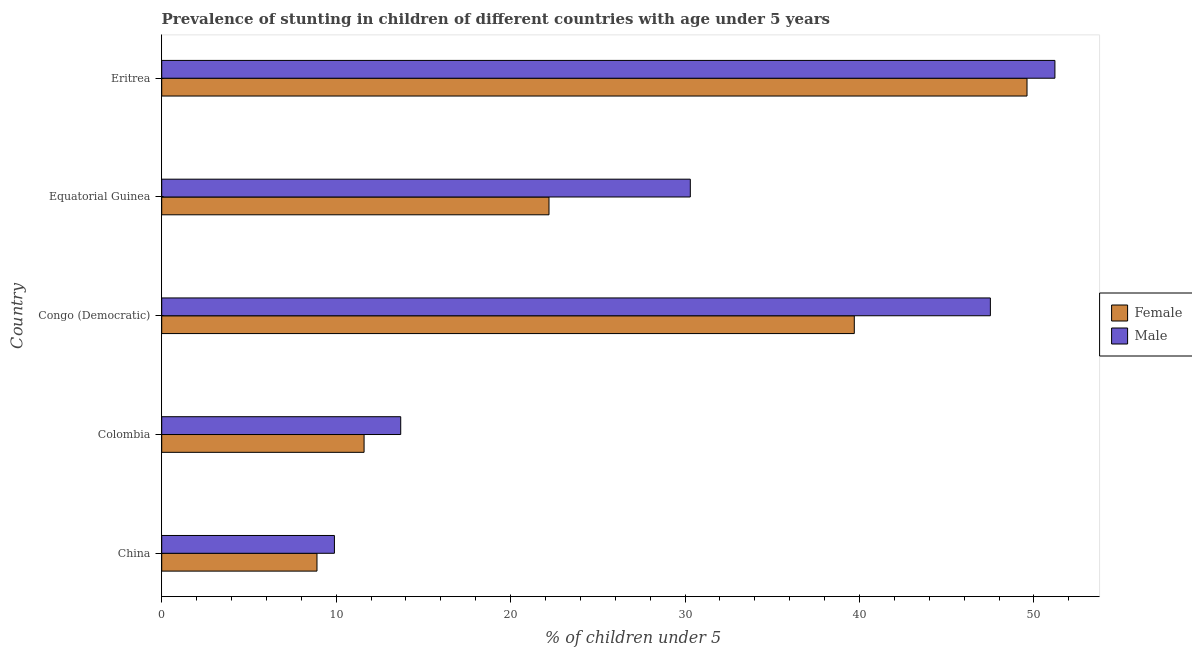How many different coloured bars are there?
Your answer should be very brief. 2. Are the number of bars on each tick of the Y-axis equal?
Your answer should be compact. Yes. How many bars are there on the 5th tick from the top?
Make the answer very short. 2. What is the label of the 1st group of bars from the top?
Keep it short and to the point. Eritrea. What is the percentage of stunted male children in Eritrea?
Provide a succinct answer. 51.2. Across all countries, what is the maximum percentage of stunted female children?
Offer a terse response. 49.6. Across all countries, what is the minimum percentage of stunted male children?
Give a very brief answer. 9.9. In which country was the percentage of stunted male children maximum?
Your response must be concise. Eritrea. What is the total percentage of stunted male children in the graph?
Give a very brief answer. 152.6. What is the difference between the percentage of stunted male children in Colombia and that in Equatorial Guinea?
Provide a succinct answer. -16.6. What is the difference between the percentage of stunted male children in Colombia and the percentage of stunted female children in Congo (Democratic)?
Your answer should be very brief. -26. What is the average percentage of stunted male children per country?
Ensure brevity in your answer.  30.52. In how many countries, is the percentage of stunted female children greater than 46 %?
Offer a very short reply. 1. What is the ratio of the percentage of stunted male children in Colombia to that in Equatorial Guinea?
Give a very brief answer. 0.45. What is the difference between the highest and the lowest percentage of stunted male children?
Provide a short and direct response. 41.3. Is the sum of the percentage of stunted female children in Congo (Democratic) and Equatorial Guinea greater than the maximum percentage of stunted male children across all countries?
Your answer should be very brief. Yes. How many bars are there?
Provide a short and direct response. 10. How many countries are there in the graph?
Provide a short and direct response. 5. Are the values on the major ticks of X-axis written in scientific E-notation?
Your answer should be compact. No. Does the graph contain any zero values?
Ensure brevity in your answer.  No. What is the title of the graph?
Keep it short and to the point. Prevalence of stunting in children of different countries with age under 5 years. What is the label or title of the X-axis?
Keep it short and to the point.  % of children under 5. What is the label or title of the Y-axis?
Keep it short and to the point. Country. What is the  % of children under 5 in Female in China?
Keep it short and to the point. 8.9. What is the  % of children under 5 of Male in China?
Provide a succinct answer. 9.9. What is the  % of children under 5 of Female in Colombia?
Offer a very short reply. 11.6. What is the  % of children under 5 in Male in Colombia?
Your response must be concise. 13.7. What is the  % of children under 5 of Female in Congo (Democratic)?
Offer a very short reply. 39.7. What is the  % of children under 5 of Male in Congo (Democratic)?
Make the answer very short. 47.5. What is the  % of children under 5 in Female in Equatorial Guinea?
Your response must be concise. 22.2. What is the  % of children under 5 of Male in Equatorial Guinea?
Your response must be concise. 30.3. What is the  % of children under 5 of Female in Eritrea?
Your answer should be very brief. 49.6. What is the  % of children under 5 in Male in Eritrea?
Ensure brevity in your answer.  51.2. Across all countries, what is the maximum  % of children under 5 of Female?
Provide a short and direct response. 49.6. Across all countries, what is the maximum  % of children under 5 in Male?
Make the answer very short. 51.2. Across all countries, what is the minimum  % of children under 5 in Female?
Offer a terse response. 8.9. Across all countries, what is the minimum  % of children under 5 in Male?
Ensure brevity in your answer.  9.9. What is the total  % of children under 5 of Female in the graph?
Offer a terse response. 132. What is the total  % of children under 5 in Male in the graph?
Give a very brief answer. 152.6. What is the difference between the  % of children under 5 of Female in China and that in Congo (Democratic)?
Keep it short and to the point. -30.8. What is the difference between the  % of children under 5 in Male in China and that in Congo (Democratic)?
Keep it short and to the point. -37.6. What is the difference between the  % of children under 5 of Male in China and that in Equatorial Guinea?
Keep it short and to the point. -20.4. What is the difference between the  % of children under 5 of Female in China and that in Eritrea?
Offer a terse response. -40.7. What is the difference between the  % of children under 5 in Male in China and that in Eritrea?
Provide a short and direct response. -41.3. What is the difference between the  % of children under 5 in Female in Colombia and that in Congo (Democratic)?
Provide a short and direct response. -28.1. What is the difference between the  % of children under 5 of Male in Colombia and that in Congo (Democratic)?
Provide a short and direct response. -33.8. What is the difference between the  % of children under 5 in Female in Colombia and that in Equatorial Guinea?
Your answer should be very brief. -10.6. What is the difference between the  % of children under 5 of Male in Colombia and that in Equatorial Guinea?
Ensure brevity in your answer.  -16.6. What is the difference between the  % of children under 5 in Female in Colombia and that in Eritrea?
Provide a short and direct response. -38. What is the difference between the  % of children under 5 of Male in Colombia and that in Eritrea?
Your answer should be compact. -37.5. What is the difference between the  % of children under 5 of Female in Congo (Democratic) and that in Equatorial Guinea?
Keep it short and to the point. 17.5. What is the difference between the  % of children under 5 in Male in Congo (Democratic) and that in Equatorial Guinea?
Your answer should be compact. 17.2. What is the difference between the  % of children under 5 of Female in Congo (Democratic) and that in Eritrea?
Ensure brevity in your answer.  -9.9. What is the difference between the  % of children under 5 in Male in Congo (Democratic) and that in Eritrea?
Provide a succinct answer. -3.7. What is the difference between the  % of children under 5 in Female in Equatorial Guinea and that in Eritrea?
Give a very brief answer. -27.4. What is the difference between the  % of children under 5 in Male in Equatorial Guinea and that in Eritrea?
Your answer should be compact. -20.9. What is the difference between the  % of children under 5 in Female in China and the  % of children under 5 in Male in Congo (Democratic)?
Provide a succinct answer. -38.6. What is the difference between the  % of children under 5 in Female in China and the  % of children under 5 in Male in Equatorial Guinea?
Provide a succinct answer. -21.4. What is the difference between the  % of children under 5 in Female in China and the  % of children under 5 in Male in Eritrea?
Your answer should be very brief. -42.3. What is the difference between the  % of children under 5 in Female in Colombia and the  % of children under 5 in Male in Congo (Democratic)?
Keep it short and to the point. -35.9. What is the difference between the  % of children under 5 in Female in Colombia and the  % of children under 5 in Male in Equatorial Guinea?
Provide a succinct answer. -18.7. What is the difference between the  % of children under 5 in Female in Colombia and the  % of children under 5 in Male in Eritrea?
Your answer should be compact. -39.6. What is the difference between the  % of children under 5 of Female in Congo (Democratic) and the  % of children under 5 of Male in Eritrea?
Ensure brevity in your answer.  -11.5. What is the difference between the  % of children under 5 of Female in Equatorial Guinea and the  % of children under 5 of Male in Eritrea?
Offer a terse response. -29. What is the average  % of children under 5 of Female per country?
Your response must be concise. 26.4. What is the average  % of children under 5 of Male per country?
Your answer should be very brief. 30.52. What is the difference between the  % of children under 5 of Female and  % of children under 5 of Male in Congo (Democratic)?
Offer a terse response. -7.8. What is the difference between the  % of children under 5 in Female and  % of children under 5 in Male in Equatorial Guinea?
Make the answer very short. -8.1. What is the ratio of the  % of children under 5 of Female in China to that in Colombia?
Make the answer very short. 0.77. What is the ratio of the  % of children under 5 in Male in China to that in Colombia?
Keep it short and to the point. 0.72. What is the ratio of the  % of children under 5 in Female in China to that in Congo (Democratic)?
Make the answer very short. 0.22. What is the ratio of the  % of children under 5 of Male in China to that in Congo (Democratic)?
Make the answer very short. 0.21. What is the ratio of the  % of children under 5 of Female in China to that in Equatorial Guinea?
Offer a terse response. 0.4. What is the ratio of the  % of children under 5 of Male in China to that in Equatorial Guinea?
Ensure brevity in your answer.  0.33. What is the ratio of the  % of children under 5 in Female in China to that in Eritrea?
Your response must be concise. 0.18. What is the ratio of the  % of children under 5 in Male in China to that in Eritrea?
Provide a succinct answer. 0.19. What is the ratio of the  % of children under 5 in Female in Colombia to that in Congo (Democratic)?
Your answer should be very brief. 0.29. What is the ratio of the  % of children under 5 of Male in Colombia to that in Congo (Democratic)?
Your answer should be compact. 0.29. What is the ratio of the  % of children under 5 in Female in Colombia to that in Equatorial Guinea?
Your answer should be compact. 0.52. What is the ratio of the  % of children under 5 in Male in Colombia to that in Equatorial Guinea?
Offer a terse response. 0.45. What is the ratio of the  % of children under 5 in Female in Colombia to that in Eritrea?
Your answer should be compact. 0.23. What is the ratio of the  % of children under 5 in Male in Colombia to that in Eritrea?
Keep it short and to the point. 0.27. What is the ratio of the  % of children under 5 in Female in Congo (Democratic) to that in Equatorial Guinea?
Provide a short and direct response. 1.79. What is the ratio of the  % of children under 5 of Male in Congo (Democratic) to that in Equatorial Guinea?
Offer a terse response. 1.57. What is the ratio of the  % of children under 5 of Female in Congo (Democratic) to that in Eritrea?
Your response must be concise. 0.8. What is the ratio of the  % of children under 5 in Male in Congo (Democratic) to that in Eritrea?
Ensure brevity in your answer.  0.93. What is the ratio of the  % of children under 5 in Female in Equatorial Guinea to that in Eritrea?
Your answer should be very brief. 0.45. What is the ratio of the  % of children under 5 of Male in Equatorial Guinea to that in Eritrea?
Keep it short and to the point. 0.59. What is the difference between the highest and the second highest  % of children under 5 of Male?
Provide a short and direct response. 3.7. What is the difference between the highest and the lowest  % of children under 5 of Female?
Provide a succinct answer. 40.7. What is the difference between the highest and the lowest  % of children under 5 of Male?
Make the answer very short. 41.3. 